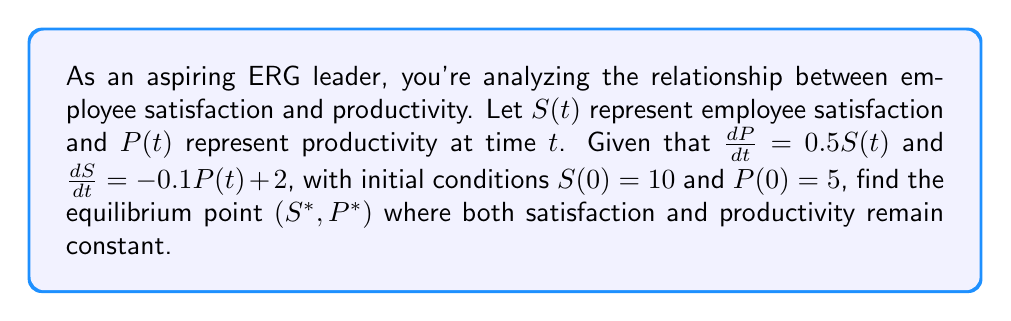Provide a solution to this math problem. 1) To find the equilibrium point, we need to set both derivatives to zero:

   $\frac{dP}{dt} = 0.5S(t) = 0$
   $\frac{dS}{dt} = -0.1P(t) + 2 = 0$

2) From the first equation:
   $0.5S^* = 0$
   $S^* = 0$

3) Substituting this into the second equation:
   $-0.1P^* + 2 = 0$
   $-0.1P^* = -2$
   $P^* = 20$

4) Therefore, the equilibrium point is $(S^*, P^*) = (0, 20)$

5) To verify, we can substitute these values back into the original equations:

   $\frac{dP}{dt} = 0.5(0) = 0$
   $\frac{dS}{dt} = -0.1(20) + 2 = 0$

   Both equations equal zero, confirming the equilibrium point.
Answer: $(0, 20)$ 